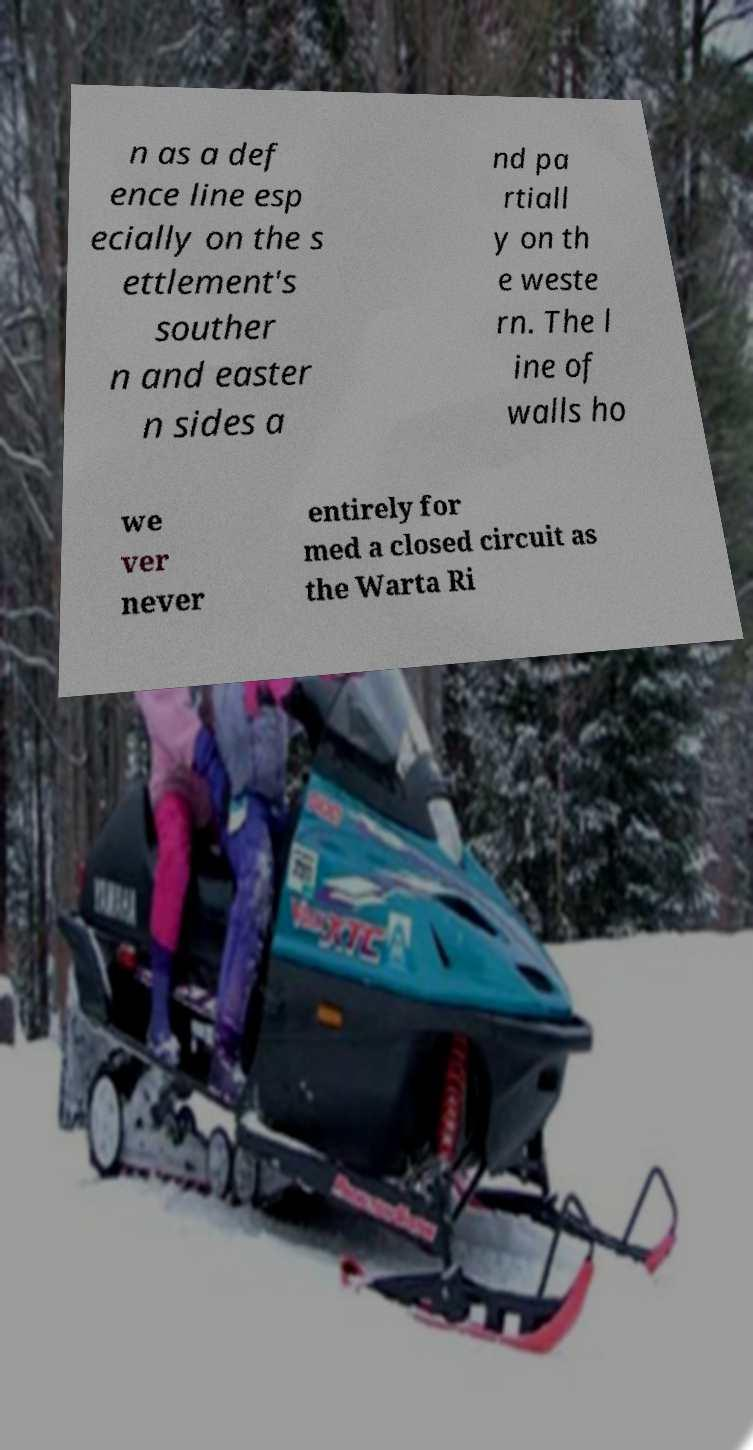What messages or text are displayed in this image? I need them in a readable, typed format. n as a def ence line esp ecially on the s ettlement's souther n and easter n sides a nd pa rtiall y on th e weste rn. The l ine of walls ho we ver never entirely for med a closed circuit as the Warta Ri 